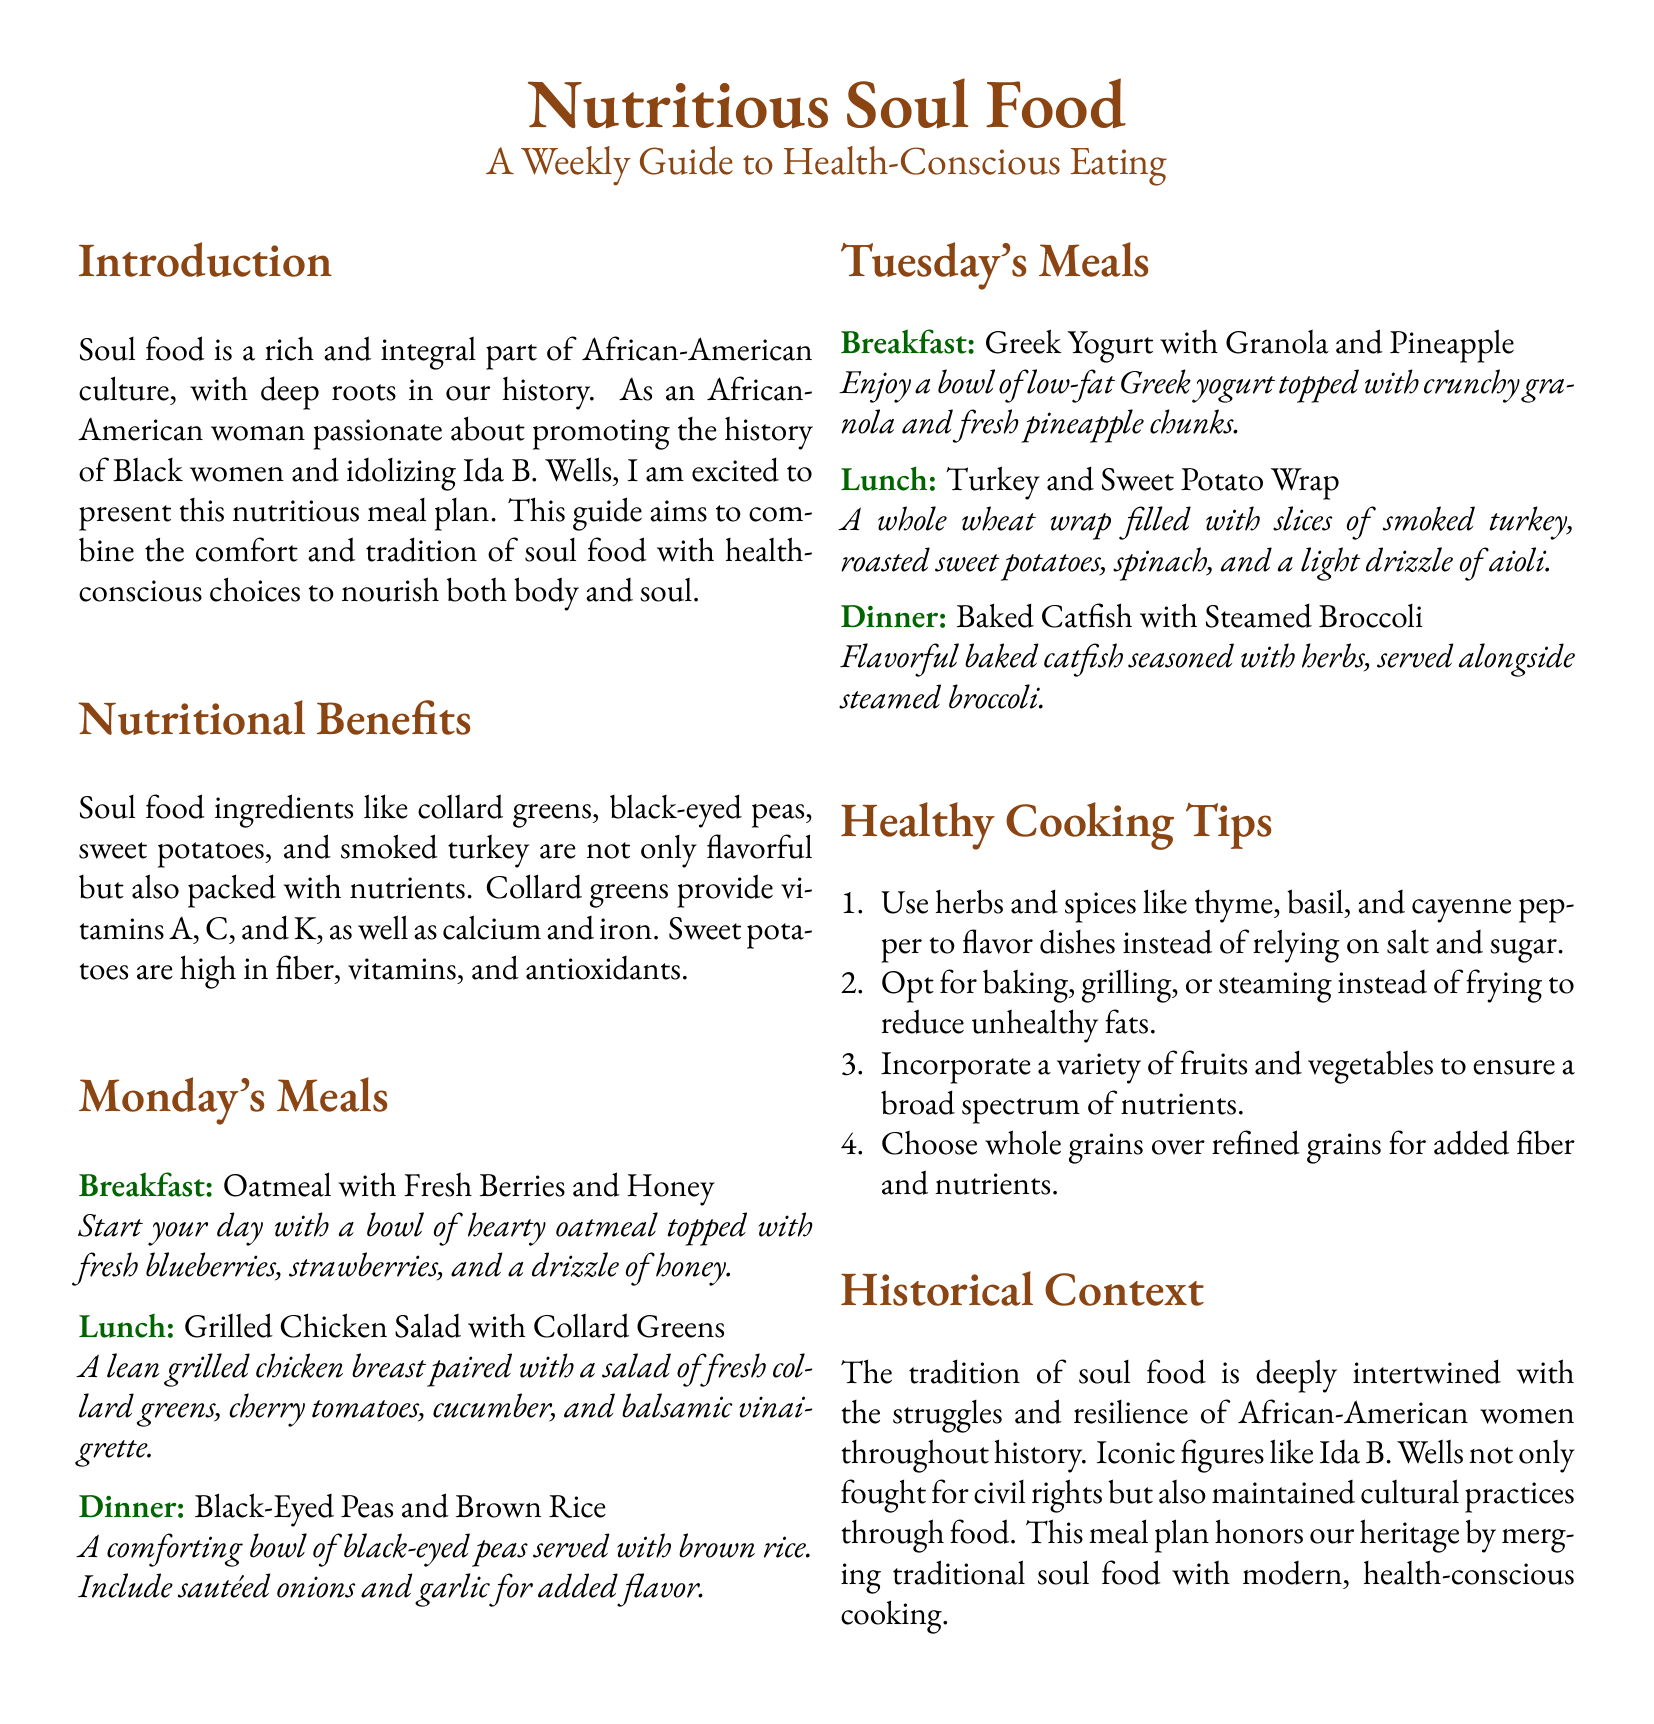What is the title of the document? The title is prominently displayed at the top of the document, stating "Nutritious Soul Food: A Weekly Guide to Health-Conscious Eating."
Answer: Nutritious Soul Food: A Weekly Guide to Health-Conscious Eating Who is honored in the historical context section? The historical context mentions an iconic figure who fought for civil rights and cultural practices, specifically noted as Ida B. Wells.
Answer: Ida B. Wells What meal is suggested for Monday's dinner? The document lists the specific meals for each day, and for Monday's dinner, it specifies a bowl of black-eyed peas and brown rice.
Answer: Black-Eyed Peas and Brown Rice Which nutrient is abundant in collard greens? The document describes various nutritional benefits of soul food ingredients, including the vitamins provided by collard greens, which are A, C, and K.
Answer: A, C, K What type of wrap is suggested for Tuesday's lunch? The document clearly states the meal type and contents for Tuesday's lunch, identifying it as a whole wheat wrap.
Answer: Whole wheat wrap How should unhealthy fats be reduced according to the healthy cooking tips? The document provides cooking methods to reduce unhealthy fats, recommending alternatives such as baking, grilling, or steaming instead of frying.
Answer: Baking, grilling, steaming What is suggested to incorporate for a broad spectrum of nutrients? The document emphasizes the importance of variety in fruits and vegetables to ensure comprehensive nutrient intake.
Answer: Fruits and vegetables What ingredient is used in the breakfast meal on Tuesday? The document details Tuesday's breakfast meal, indicating it consists of low-fat Greek yogurt topped with granola and pineapple.
Answer: Greek yogurt 